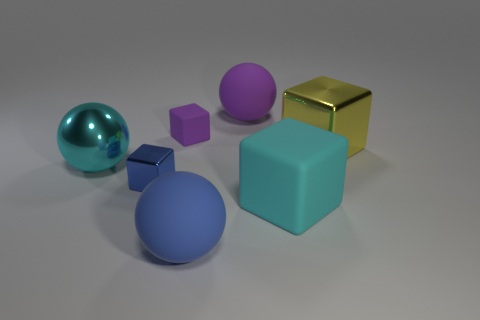Does the metal cube that is behind the metallic ball have the same size as the small blue thing?
Give a very brief answer. No. Are the cyan object that is on the right side of the big purple thing and the big cube behind the tiny blue metal thing made of the same material?
Provide a succinct answer. No. Is there a purple thing of the same size as the yellow thing?
Your answer should be compact. Yes. There is a large object that is behind the matte cube that is to the left of the large sphere that is in front of the large metal ball; what is its shape?
Your response must be concise. Sphere. Is the number of cubes that are in front of the small blue thing greater than the number of blue balls?
Your answer should be compact. No. Is there a gray object that has the same shape as the large blue matte object?
Ensure brevity in your answer.  No. Is the material of the blue block the same as the sphere that is in front of the tiny shiny block?
Your answer should be very brief. No. What is the color of the small rubber thing?
Provide a succinct answer. Purple. How many cyan matte things are behind the cyan thing on the right side of the purple rubber sphere that is behind the large metal ball?
Give a very brief answer. 0. Are there any big yellow metal objects in front of the small rubber object?
Provide a short and direct response. Yes. 